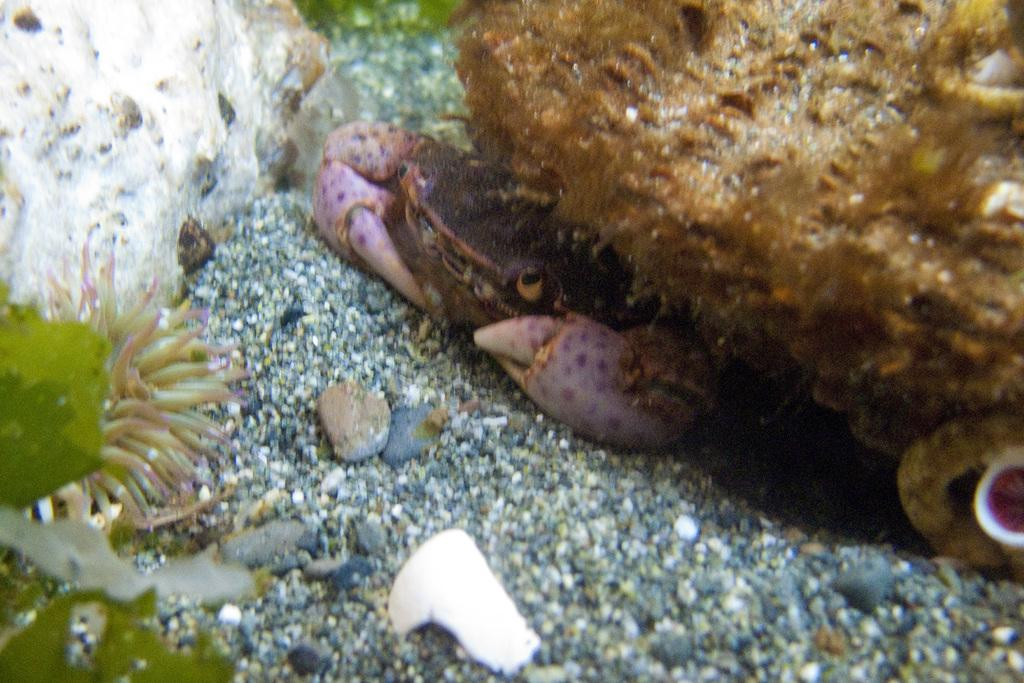What type of animal is in the image? There is a crab in the image. What else can be seen in the image besides the crab? There are stones in the image. What color is the background of the image? The background of the image is green. Where are the trousers stored in the image? There are no trousers present in the image. What type of rock can be seen in the image? There are no rocks present in the image; there are only stones. 